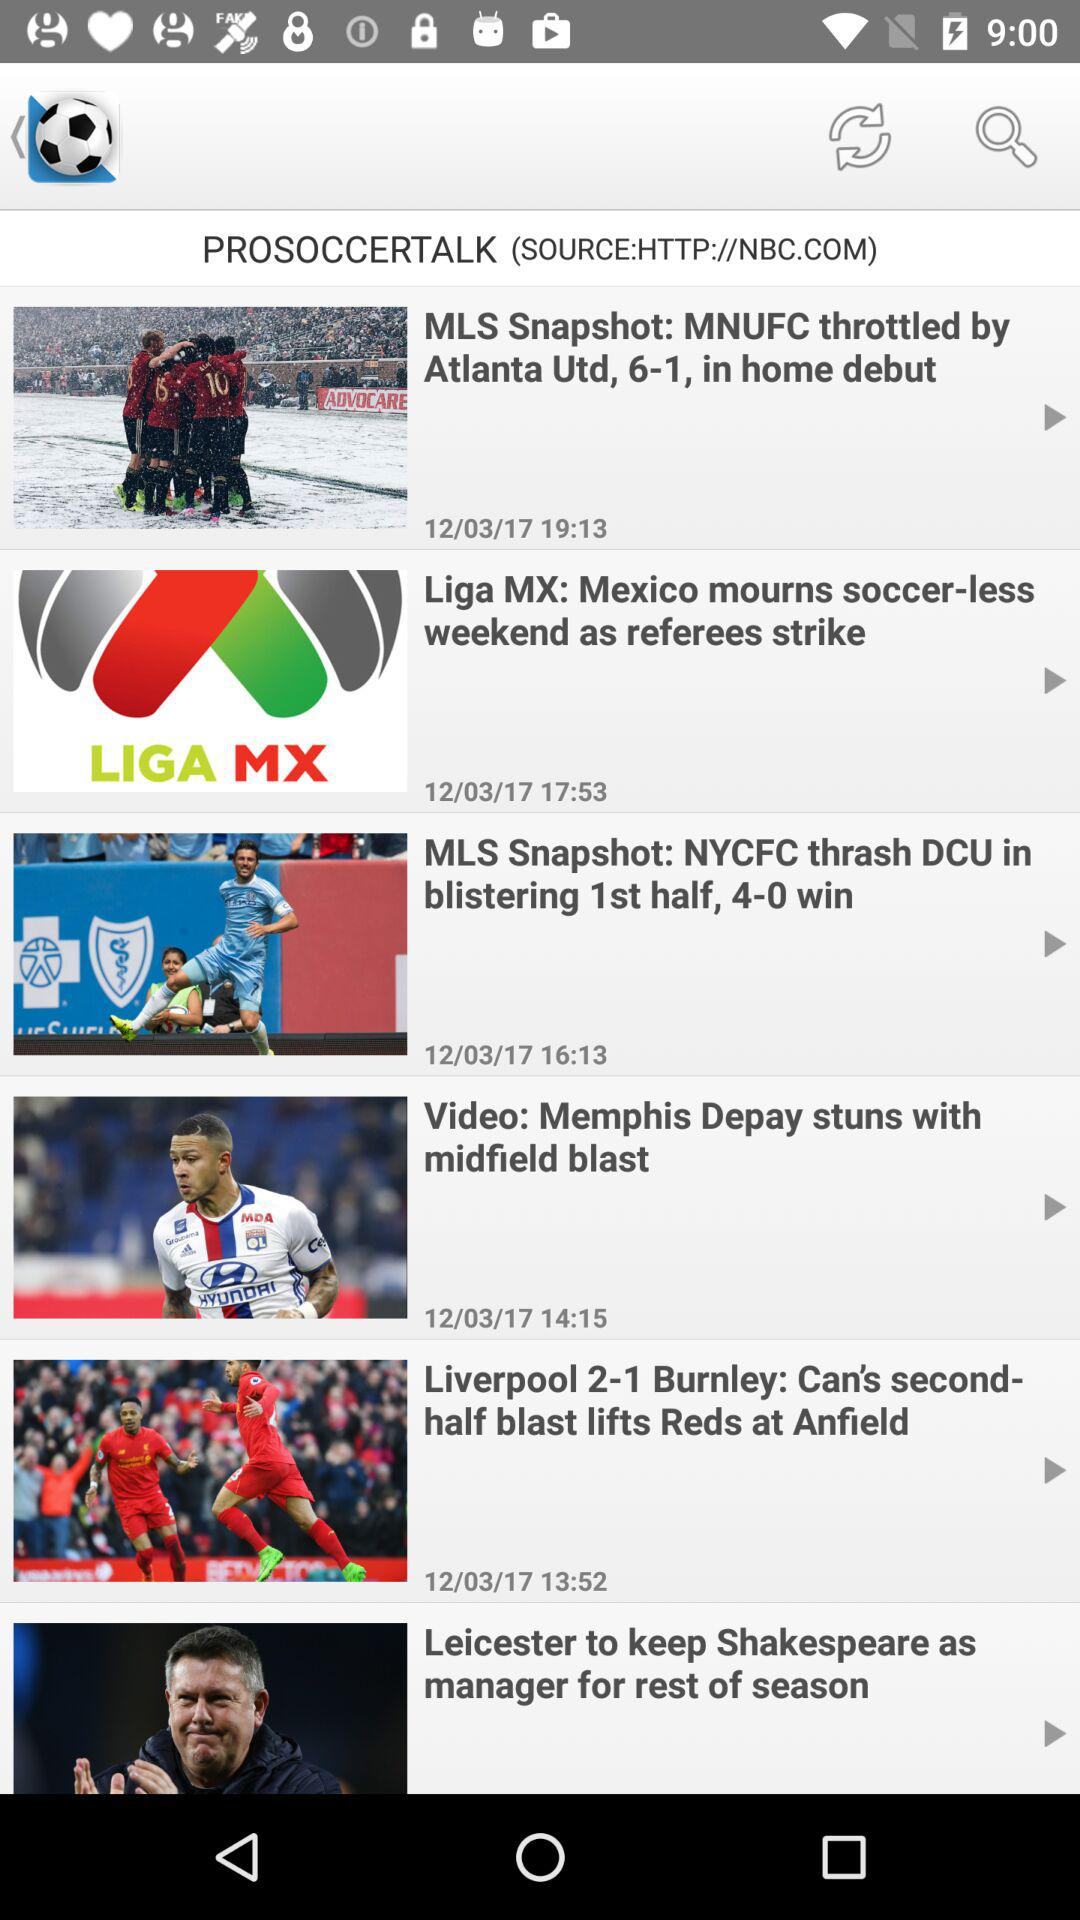What is the publication date of the Liga MX? The publication date is 12/03/17. 